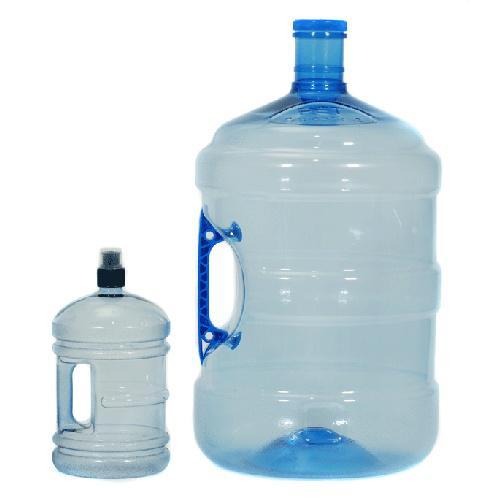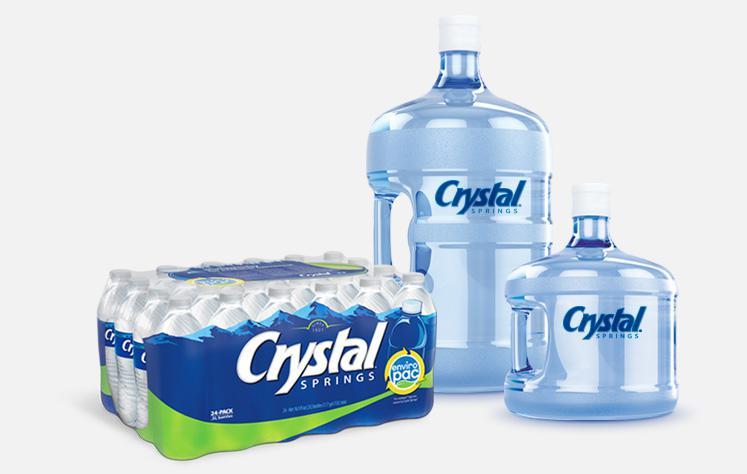The first image is the image on the left, the second image is the image on the right. Evaluate the accuracy of this statement regarding the images: "There is a bottle laying sideways in one of the images.". Is it true? Answer yes or no. No. The first image is the image on the left, the second image is the image on the right. Evaluate the accuracy of this statement regarding the images: "An image shows an upright water bottle next to one lying on its side.". Is it true? Answer yes or no. No. 